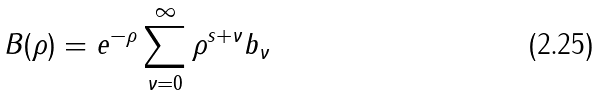Convert formula to latex. <formula><loc_0><loc_0><loc_500><loc_500>B ( \rho ) = e ^ { - \rho } \sum _ { \nu = 0 } ^ { \infty } \rho ^ { s + \nu } b _ { \nu }</formula> 